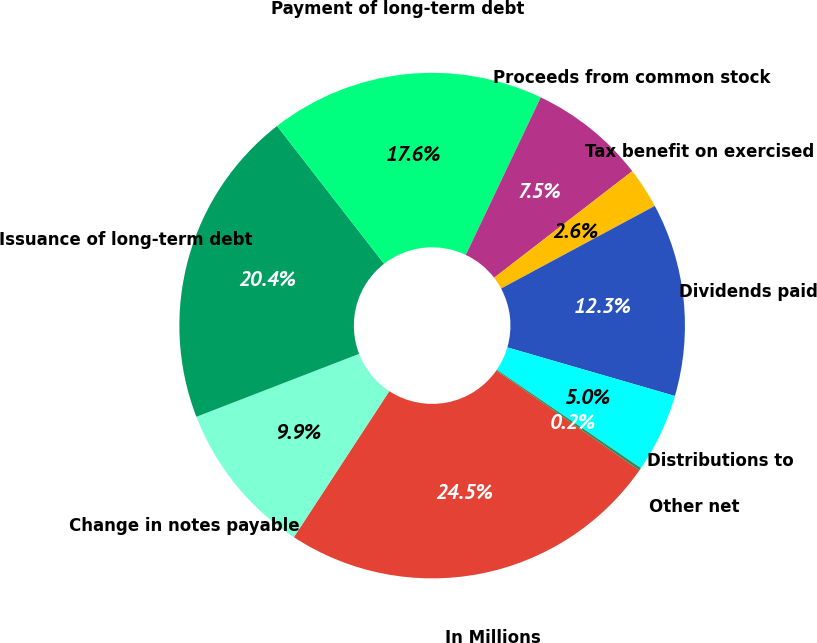Convert chart to OTSL. <chart><loc_0><loc_0><loc_500><loc_500><pie_chart><fcel>In Millions<fcel>Change in notes payable<fcel>Issuance of long-term debt<fcel>Payment of long-term debt<fcel>Proceeds from common stock<fcel>Tax benefit on exercised<fcel>Dividends paid<fcel>Distributions to<fcel>Other net<nl><fcel>24.51%<fcel>9.91%<fcel>20.36%<fcel>17.58%<fcel>7.47%<fcel>2.61%<fcel>12.34%<fcel>5.04%<fcel>0.17%<nl></chart> 